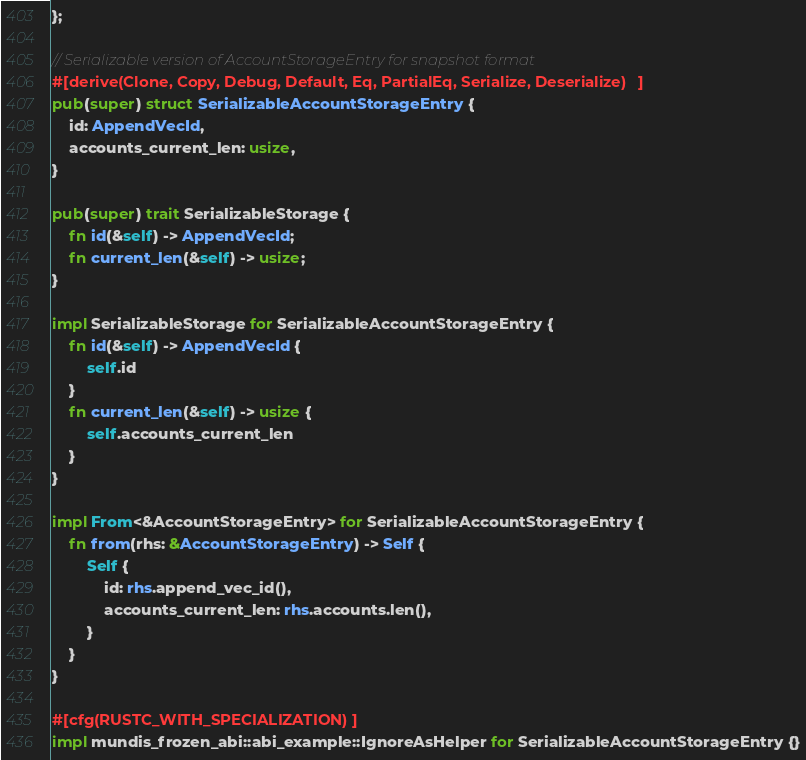<code> <loc_0><loc_0><loc_500><loc_500><_Rust_>};

// Serializable version of AccountStorageEntry for snapshot format
#[derive(Clone, Copy, Debug, Default, Eq, PartialEq, Serialize, Deserialize)]
pub(super) struct SerializableAccountStorageEntry {
    id: AppendVecId,
    accounts_current_len: usize,
}

pub(super) trait SerializableStorage {
    fn id(&self) -> AppendVecId;
    fn current_len(&self) -> usize;
}

impl SerializableStorage for SerializableAccountStorageEntry {
    fn id(&self) -> AppendVecId {
        self.id
    }
    fn current_len(&self) -> usize {
        self.accounts_current_len
    }
}

impl From<&AccountStorageEntry> for SerializableAccountStorageEntry {
    fn from(rhs: &AccountStorageEntry) -> Self {
        Self {
            id: rhs.append_vec_id(),
            accounts_current_len: rhs.accounts.len(),
        }
    }
}

#[cfg(RUSTC_WITH_SPECIALIZATION)]
impl mundis_frozen_abi::abi_example::IgnoreAsHelper for SerializableAccountStorageEntry {}
</code> 